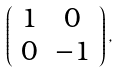Convert formula to latex. <formula><loc_0><loc_0><loc_500><loc_500>\left ( \begin{array} { c c } 1 & 0 \\ 0 & - 1 \\ \end{array} \right ) ,</formula> 